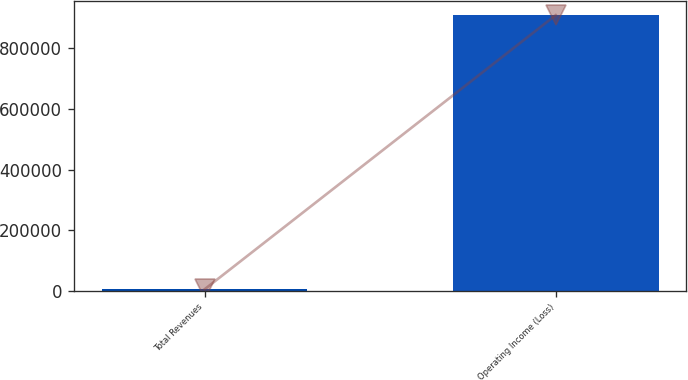Convert chart. <chart><loc_0><loc_0><loc_500><loc_500><bar_chart><fcel>Total Revenues<fcel>Operating Income (Loss)<nl><fcel>4609<fcel>910109<nl></chart> 